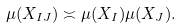Convert formula to latex. <formula><loc_0><loc_0><loc_500><loc_500>\mu ( X _ { I J } ) \asymp \mu ( X _ { I } ) \mu ( X _ { J } ) .</formula> 